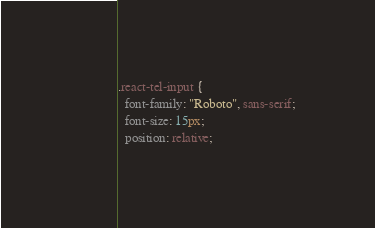Convert code to text. <code><loc_0><loc_0><loc_500><loc_500><_CSS_>.react-tel-input {
  font-family: "Roboto", sans-serif;
  font-size: 15px;
  position: relative;</code> 